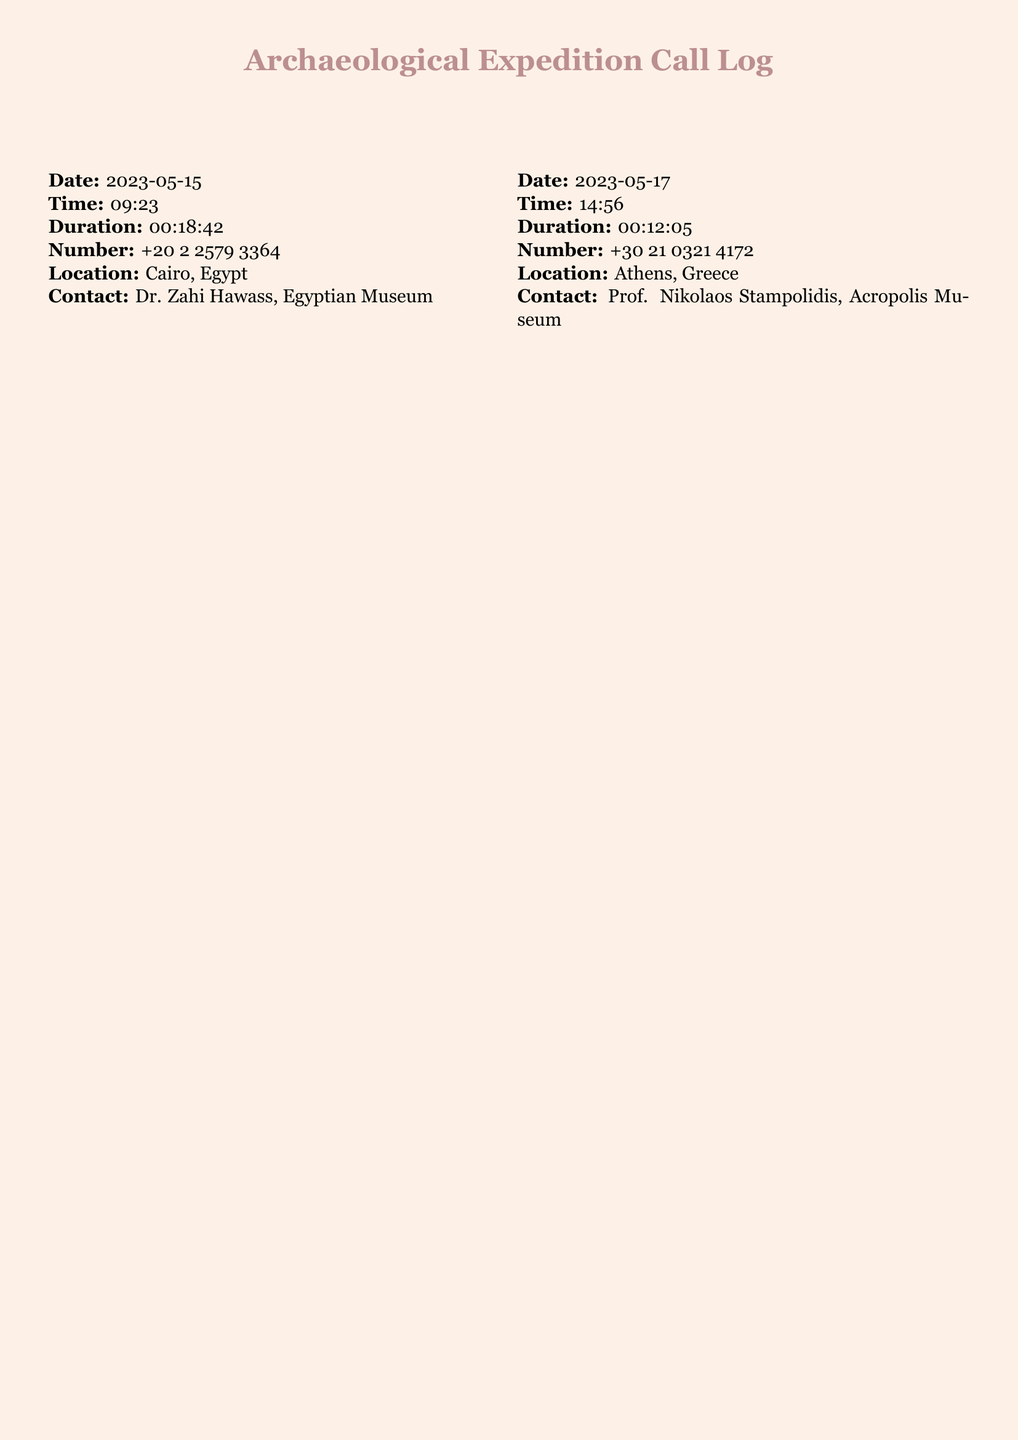What is the date of the first call? The first call is recorded on 2023-05-15.
Answer: 2023-05-15 Who is the contact associated with the call to Cairo, Egypt? The contact for Cairo, Egypt is Dr. Zahi Hawass.
Answer: Dr. Zahi Hawass What is the duration of the call made on May 20th? The call made on May 20th lasted for 00:25:30.
Answer: 00:25:30 Which city was the call from on May 28th? The call on May 28th was from Rome, Italy.
Answer: Rome, Italy How many calls were made to contacts in Peru? There is one call recorded to a contact in Peru.
Answer: One What country has a contact from the British Museum? The British Museum is located in the United Kingdom.
Answer: United Kingdom What is the phone number for the contact in Athens? The phone number for the contact in Athens is +30 21 0321 4172.
Answer: +30 21 0321 4172 Which museum is associated with Dr. Leonardo López Luján? Dr. Leonardo López Luján is associated with Templo Mayor Museum.
Answer: Templo Mayor Museum What is the duration of the shortest call in the log? The shortest call is recorded for 00:09:18.
Answer: 00:09:18 Who is the contact at the Colosseum Archaeological Park? The contact is Dr. Alfonsina Russo.
Answer: Dr. Alfonsina Russo 